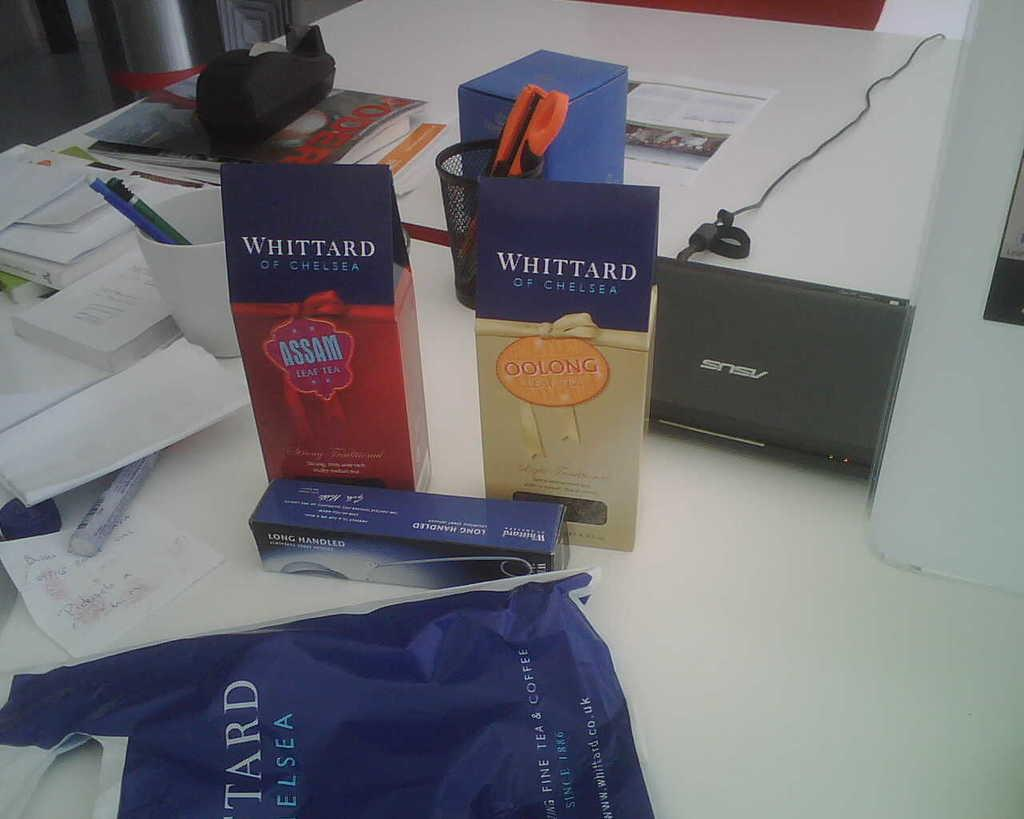<image>
Describe the image concisely. Box of Whittard Oolong next to a box of Whittard Assam. 